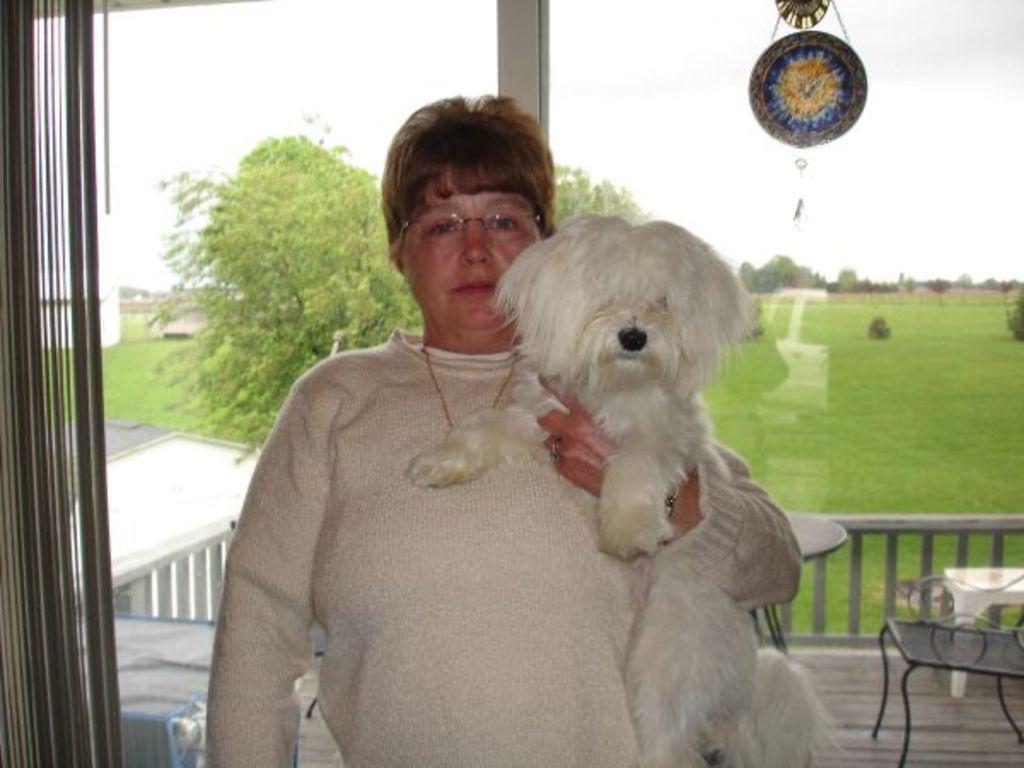Could you give a brief overview of what you see in this image? In this image I see a woman who is holding the dog. In the background i see a table, a chair, few trees and the grass. 